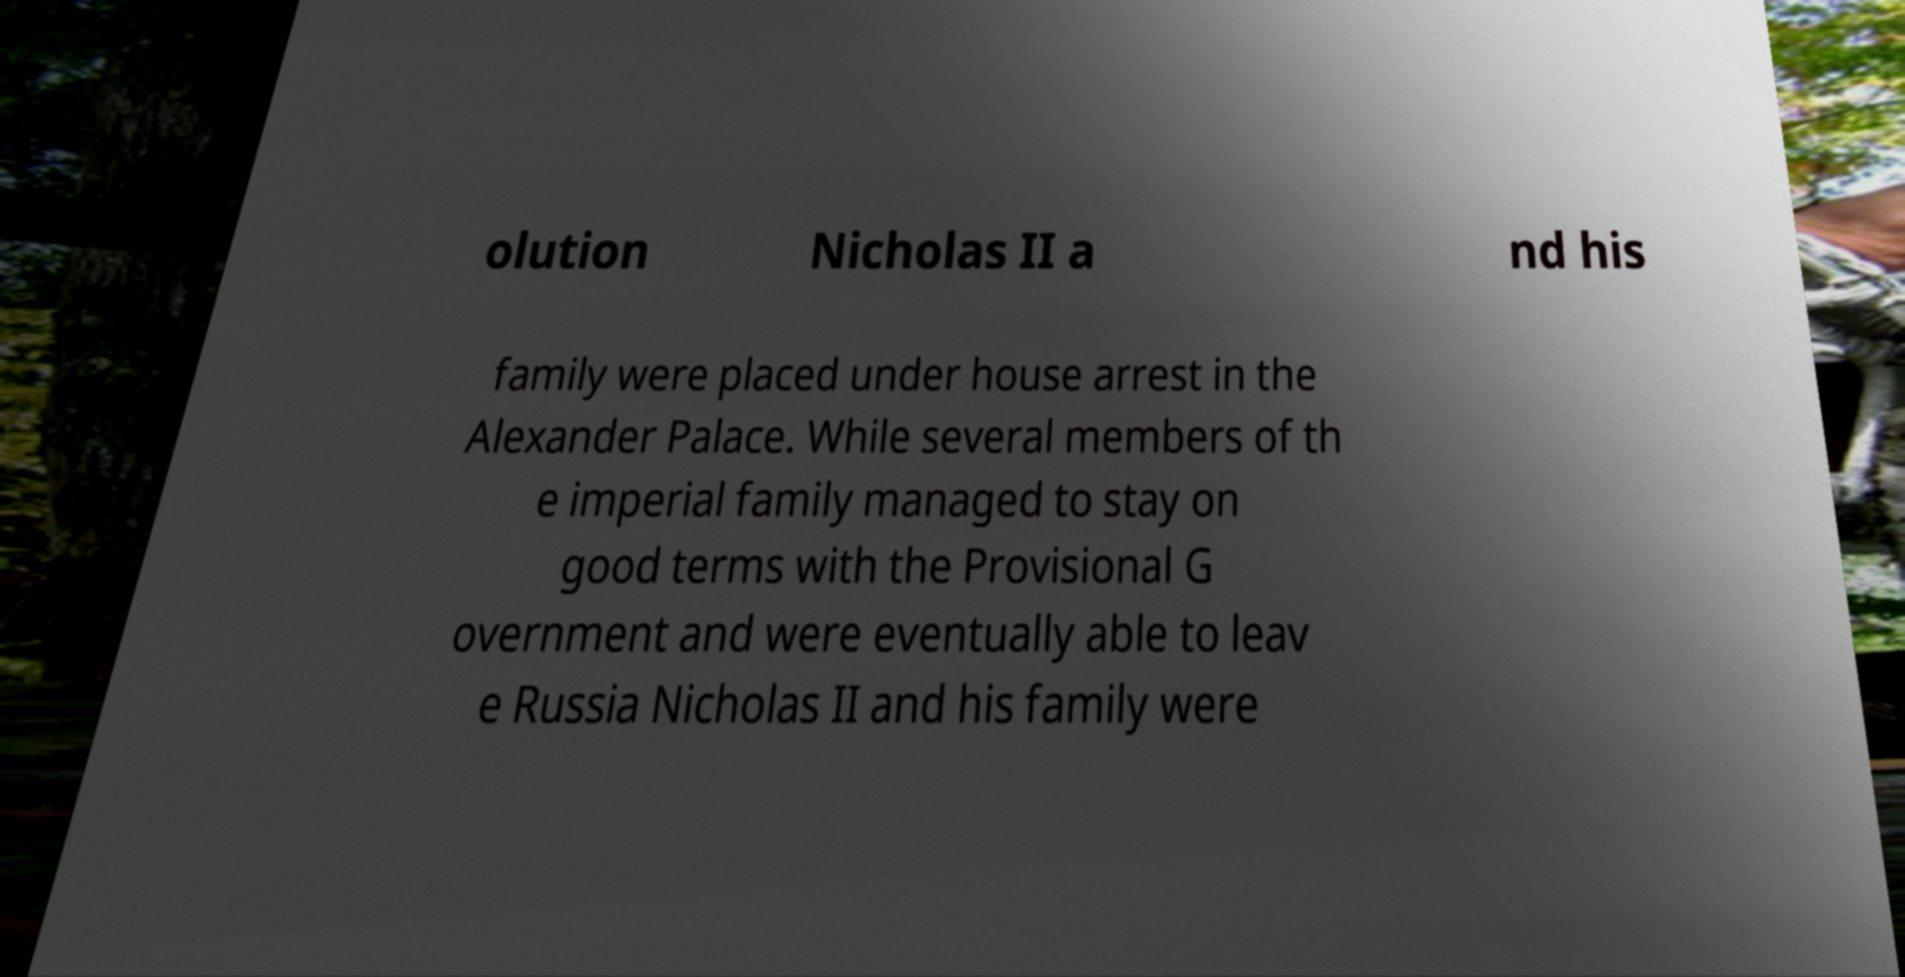What messages or text are displayed in this image? I need them in a readable, typed format. olution Nicholas II a nd his family were placed under house arrest in the Alexander Palace. While several members of th e imperial family managed to stay on good terms with the Provisional G overnment and were eventually able to leav e Russia Nicholas II and his family were 